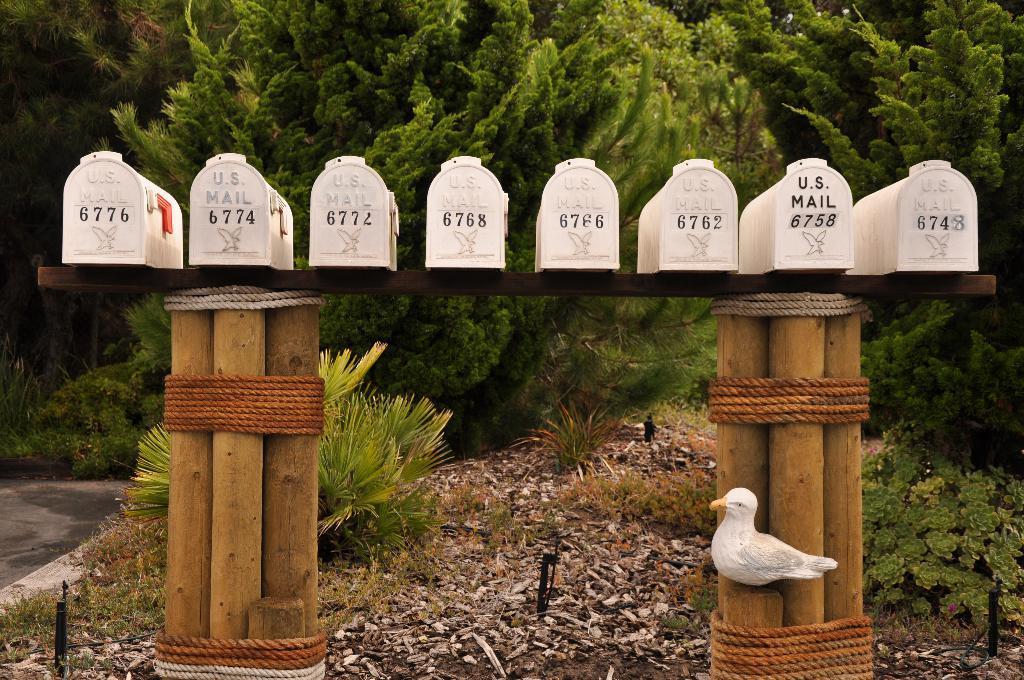Can you describe this image briefly? In this image we can see boxes with numbers on a wooden stand. And the stand is made with wooden pieces tied with ropes. There is a statue of a bird. In the back there are plants. Also there are trees. 